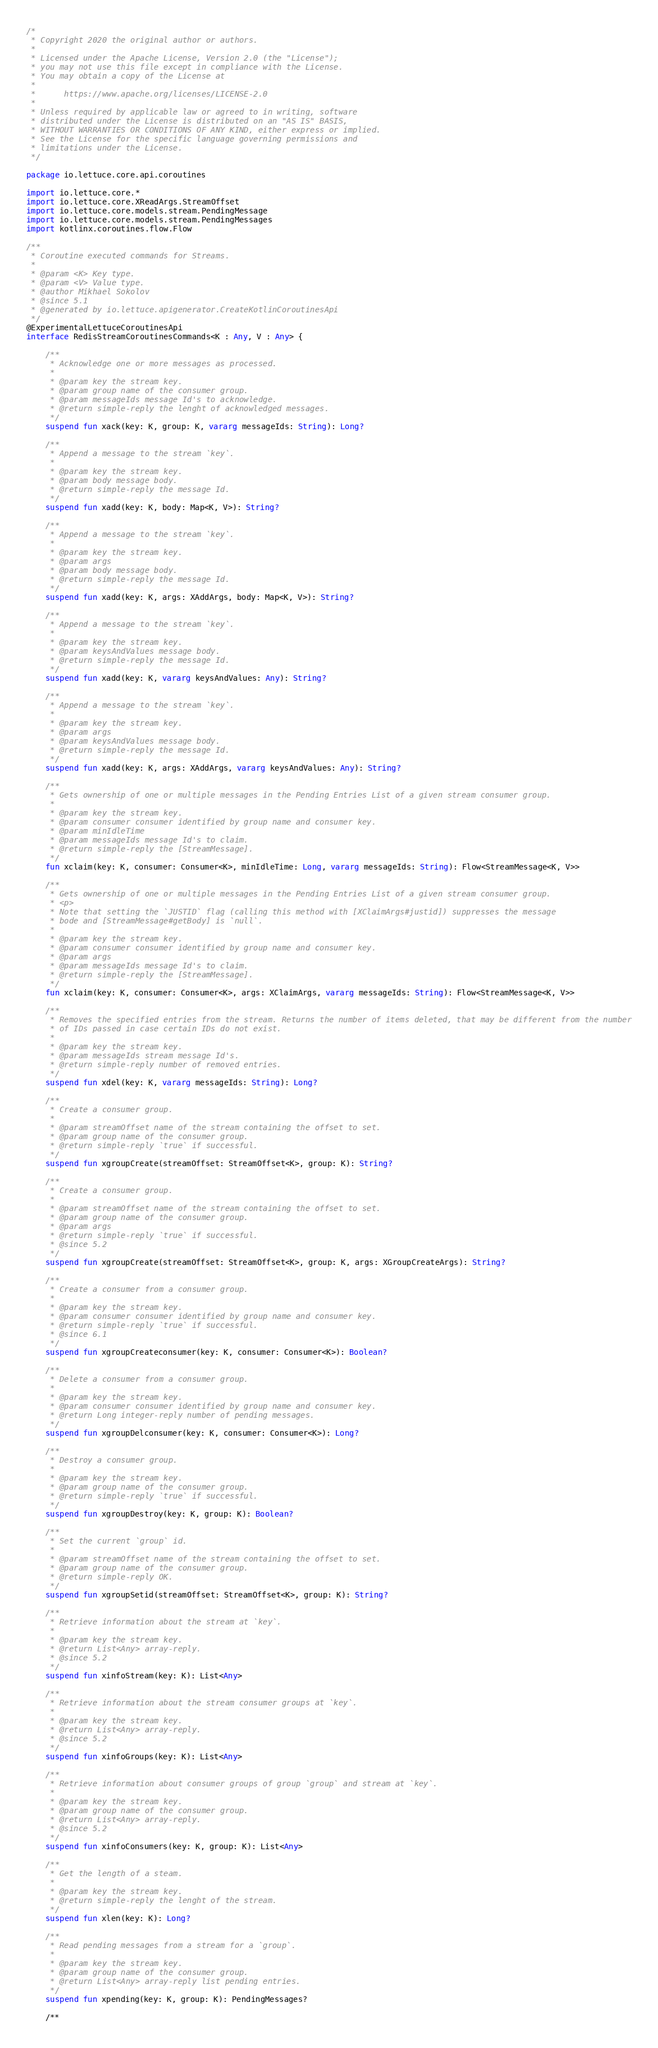Convert code to text. <code><loc_0><loc_0><loc_500><loc_500><_Kotlin_>/*
 * Copyright 2020 the original author or authors.
 *
 * Licensed under the Apache License, Version 2.0 (the "License");
 * you may not use this file except in compliance with the License.
 * You may obtain a copy of the License at
 *
 *      https://www.apache.org/licenses/LICENSE-2.0
 *
 * Unless required by applicable law or agreed to in writing, software
 * distributed under the License is distributed on an "AS IS" BASIS,
 * WITHOUT WARRANTIES OR CONDITIONS OF ANY KIND, either express or implied.
 * See the License for the specific language governing permissions and
 * limitations under the License.
 */

package io.lettuce.core.api.coroutines

import io.lettuce.core.*
import io.lettuce.core.XReadArgs.StreamOffset
import io.lettuce.core.models.stream.PendingMessage
import io.lettuce.core.models.stream.PendingMessages
import kotlinx.coroutines.flow.Flow

/**
 * Coroutine executed commands for Streams.
 *
 * @param <K> Key type.
 * @param <V> Value type.
 * @author Mikhael Sokolov
 * @since 5.1
 * @generated by io.lettuce.apigenerator.CreateKotlinCoroutinesApi
 */
@ExperimentalLettuceCoroutinesApi
interface RedisStreamCoroutinesCommands<K : Any, V : Any> {

    /**
     * Acknowledge one or more messages as processed.
     *
     * @param key the stream key.
     * @param group name of the consumer group.
     * @param messageIds message Id's to acknowledge.
     * @return simple-reply the lenght of acknowledged messages.
     */
    suspend fun xack(key: K, group: K, vararg messageIds: String): Long?

    /**
     * Append a message to the stream `key`.
     *
     * @param key the stream key.
     * @param body message body.
     * @return simple-reply the message Id.
     */
    suspend fun xadd(key: K, body: Map<K, V>): String?

    /**
     * Append a message to the stream `key`.
     *
     * @param key the stream key.
     * @param args
     * @param body message body.
     * @return simple-reply the message Id.
     */
    suspend fun xadd(key: K, args: XAddArgs, body: Map<K, V>): String?

    /**
     * Append a message to the stream `key`.
     *
     * @param key the stream key.
     * @param keysAndValues message body.
     * @return simple-reply the message Id.
     */
    suspend fun xadd(key: K, vararg keysAndValues: Any): String?

    /**
     * Append a message to the stream `key`.
     *
     * @param key the stream key.
     * @param args
     * @param keysAndValues message body.
     * @return simple-reply the message Id.
     */
    suspend fun xadd(key: K, args: XAddArgs, vararg keysAndValues: Any): String?

    /**
     * Gets ownership of one or multiple messages in the Pending Entries List of a given stream consumer group.
     *
     * @param key the stream key.
     * @param consumer consumer identified by group name and consumer key.
     * @param minIdleTime
     * @param messageIds message Id's to claim.
     * @return simple-reply the [StreamMessage].
     */
    fun xclaim(key: K, consumer: Consumer<K>, minIdleTime: Long, vararg messageIds: String): Flow<StreamMessage<K, V>>

    /**
     * Gets ownership of one or multiple messages in the Pending Entries List of a given stream consumer group.
     * <p>
     * Note that setting the `JUSTID` flag (calling this method with [XClaimArgs#justid]) suppresses the message
     * bode and [StreamMessage#getBody] is `null`.
     *
     * @param key the stream key.
     * @param consumer consumer identified by group name and consumer key.
     * @param args
     * @param messageIds message Id's to claim.
     * @return simple-reply the [StreamMessage].
     */
    fun xclaim(key: K, consumer: Consumer<K>, args: XClaimArgs, vararg messageIds: String): Flow<StreamMessage<K, V>>

    /**
     * Removes the specified entries from the stream. Returns the number of items deleted, that may be different from the number
     * of IDs passed in case certain IDs do not exist.
     *
     * @param key the stream key.
     * @param messageIds stream message Id's.
     * @return simple-reply number of removed entries.
     */
    suspend fun xdel(key: K, vararg messageIds: String): Long?

    /**
     * Create a consumer group.
     *
     * @param streamOffset name of the stream containing the offset to set.
     * @param group name of the consumer group.
     * @return simple-reply `true` if successful.
     */
    suspend fun xgroupCreate(streamOffset: StreamOffset<K>, group: K): String?

    /**
     * Create a consumer group.
     *
     * @param streamOffset name of the stream containing the offset to set.
     * @param group name of the consumer group.
     * @param args
     * @return simple-reply `true` if successful.
     * @since 5.2
     */
    suspend fun xgroupCreate(streamOffset: StreamOffset<K>, group: K, args: XGroupCreateArgs): String?

    /**
     * Create a consumer from a consumer group.
     *
     * @param key the stream key.
     * @param consumer consumer identified by group name and consumer key.
     * @return simple-reply `true` if successful.
     * @since 6.1
     */
    suspend fun xgroupCreateconsumer(key: K, consumer: Consumer<K>): Boolean?

    /**
     * Delete a consumer from a consumer group.
     *
     * @param key the stream key.
     * @param consumer consumer identified by group name and consumer key.
     * @return Long integer-reply number of pending messages.
     */
    suspend fun xgroupDelconsumer(key: K, consumer: Consumer<K>): Long?

    /**
     * Destroy a consumer group.
     *
     * @param key the stream key.
     * @param group name of the consumer group.
     * @return simple-reply `true` if successful.
     */
    suspend fun xgroupDestroy(key: K, group: K): Boolean?

    /**
     * Set the current `group` id.
     *
     * @param streamOffset name of the stream containing the offset to set.
     * @param group name of the consumer group.
     * @return simple-reply OK.
     */
    suspend fun xgroupSetid(streamOffset: StreamOffset<K>, group: K): String?

    /**
     * Retrieve information about the stream at `key`.
     *
     * @param key the stream key.
     * @return List<Any> array-reply.
     * @since 5.2
     */
    suspend fun xinfoStream(key: K): List<Any>

    /**
     * Retrieve information about the stream consumer groups at `key`.
     *
     * @param key the stream key.
     * @return List<Any> array-reply.
     * @since 5.2
     */
    suspend fun xinfoGroups(key: K): List<Any>

    /**
     * Retrieve information about consumer groups of group `group` and stream at `key`.
     *
     * @param key the stream key.
     * @param group name of the consumer group.
     * @return List<Any> array-reply.
     * @since 5.2
     */
    suspend fun xinfoConsumers(key: K, group: K): List<Any>

    /**
     * Get the length of a steam.
     *
     * @param key the stream key.
     * @return simple-reply the lenght of the stream.
     */
    suspend fun xlen(key: K): Long?

    /**
     * Read pending messages from a stream for a `group`.
     *
     * @param key the stream key.
     * @param group name of the consumer group.
     * @return List<Any> array-reply list pending entries.
     */
    suspend fun xpending(key: K, group: K): PendingMessages?

    /**</code> 